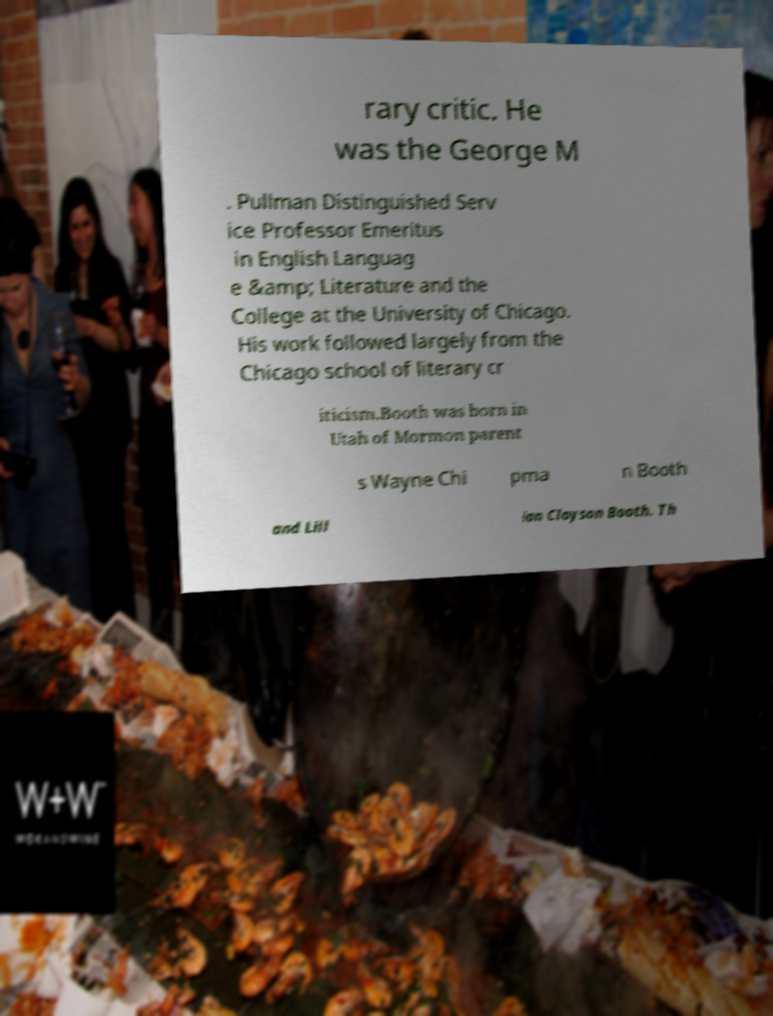For documentation purposes, I need the text within this image transcribed. Could you provide that? rary critic. He was the George M . Pullman Distinguished Serv ice Professor Emeritus in English Languag e &amp; Literature and the College at the University of Chicago. His work followed largely from the Chicago school of literary cr iticism.Booth was born in Utah of Mormon parent s Wayne Chi pma n Booth and Lill ian Clayson Booth. Th 